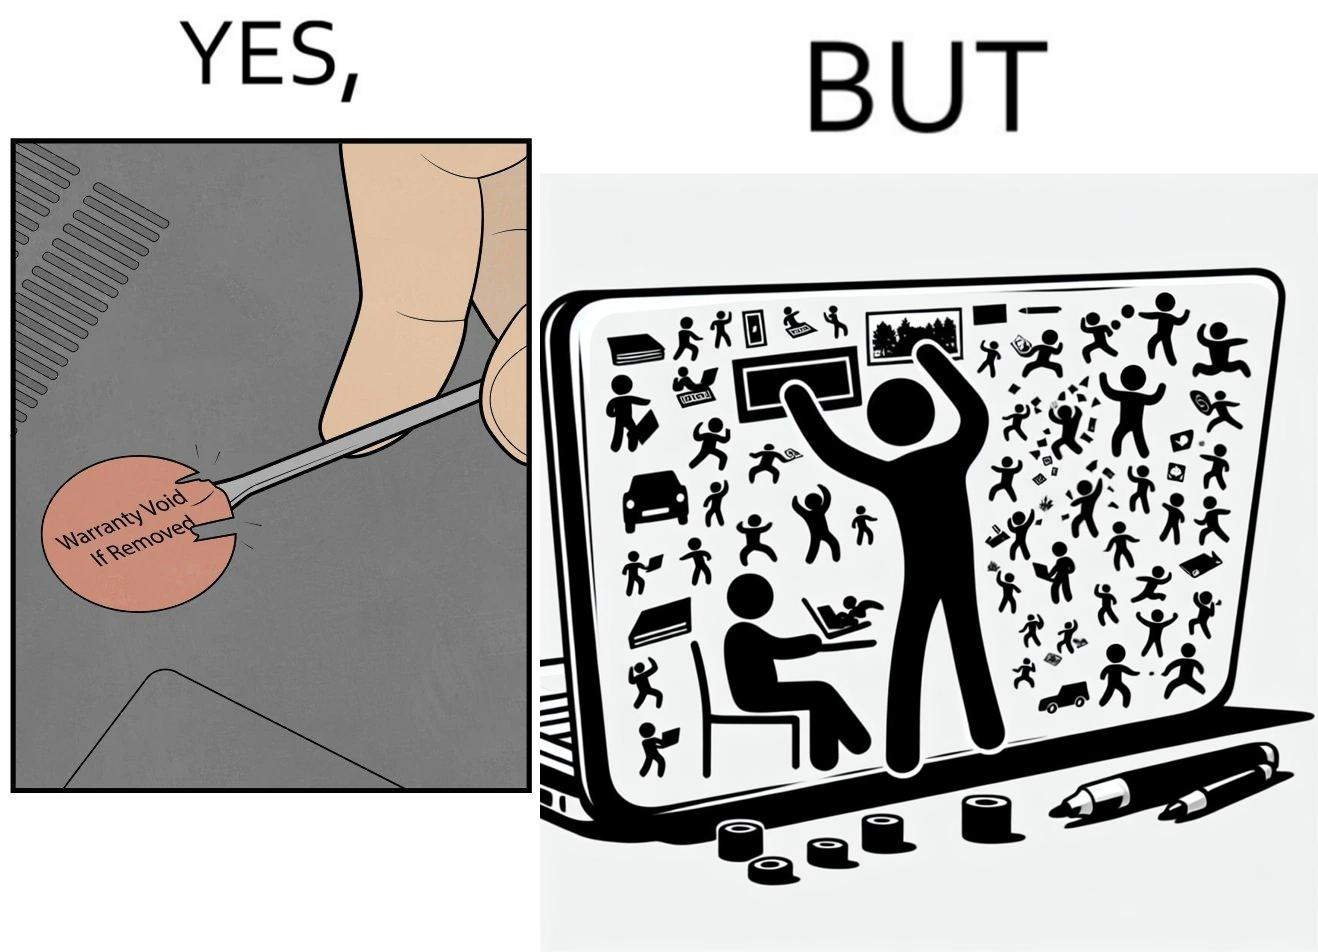What is shown in the left half versus the right half of this image? In the left part of the image: It is a warranty sticker being removed with a screwdriver In the right part of the image: It is an user sticking multiple stickers on their laptop 